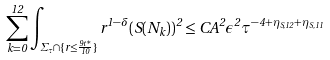Convert formula to latex. <formula><loc_0><loc_0><loc_500><loc_500>\sum _ { k = 0 } ^ { 1 2 } \int _ { \Sigma _ { \tau } \cap \{ r \leq \frac { 9 t ^ { * } } { 1 0 } \} } r ^ { 1 - \delta } ( S ( N _ { k } ) ) ^ { 2 } \leq C A ^ { 2 } \epsilon ^ { 2 } \tau ^ { - 4 + \eta _ { S , 1 2 } + \eta _ { S , 1 1 } }</formula> 